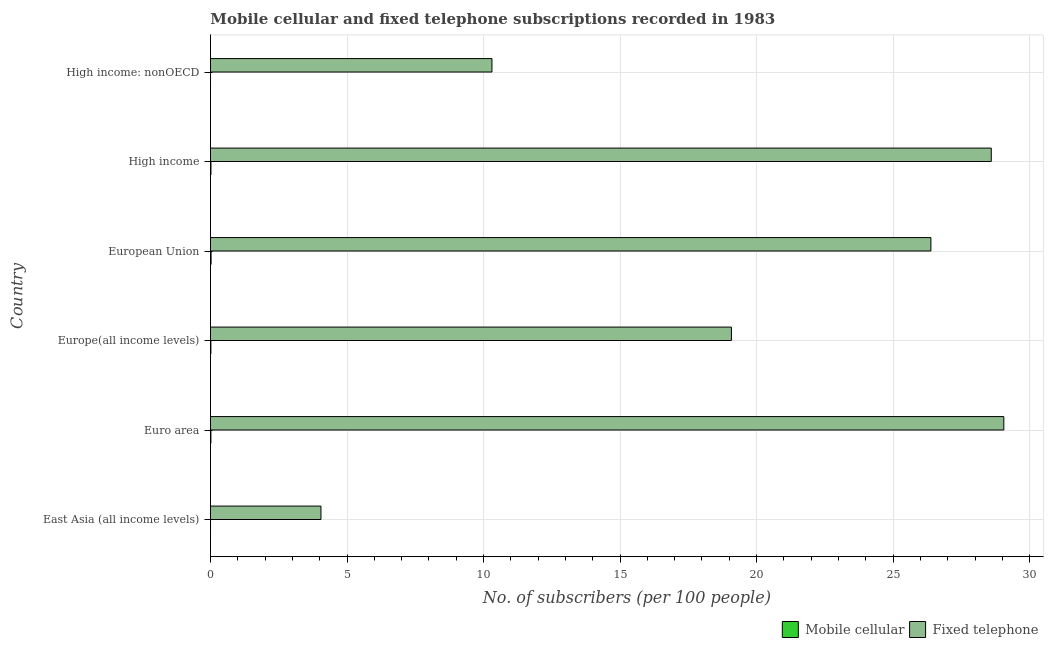How many groups of bars are there?
Your answer should be very brief. 6. Are the number of bars on each tick of the Y-axis equal?
Make the answer very short. Yes. What is the label of the 4th group of bars from the top?
Make the answer very short. Europe(all income levels). What is the number of fixed telephone subscribers in High income?
Keep it short and to the point. 28.59. Across all countries, what is the maximum number of fixed telephone subscribers?
Offer a terse response. 29.05. Across all countries, what is the minimum number of fixed telephone subscribers?
Ensure brevity in your answer.  4.05. In which country was the number of fixed telephone subscribers minimum?
Provide a succinct answer. East Asia (all income levels). What is the total number of mobile cellular subscribers in the graph?
Make the answer very short. 0.07. What is the difference between the number of fixed telephone subscribers in East Asia (all income levels) and that in Europe(all income levels)?
Provide a succinct answer. -15.03. What is the difference between the number of fixed telephone subscribers in High income and the number of mobile cellular subscribers in Euro area?
Keep it short and to the point. 28.58. What is the average number of fixed telephone subscribers per country?
Your answer should be very brief. 19.58. What is the difference between the number of mobile cellular subscribers and number of fixed telephone subscribers in High income?
Your answer should be very brief. -28.58. In how many countries, is the number of mobile cellular subscribers greater than 12 ?
Offer a terse response. 0. What is the ratio of the number of mobile cellular subscribers in Europe(all income levels) to that in European Union?
Offer a terse response. 0.7. What is the difference between the highest and the second highest number of mobile cellular subscribers?
Give a very brief answer. 0.01. Is the sum of the number of fixed telephone subscribers in East Asia (all income levels) and Europe(all income levels) greater than the maximum number of mobile cellular subscribers across all countries?
Provide a short and direct response. Yes. What does the 1st bar from the top in European Union represents?
Your answer should be compact. Fixed telephone. What does the 2nd bar from the bottom in Euro area represents?
Offer a terse response. Fixed telephone. What is the difference between two consecutive major ticks on the X-axis?
Your answer should be compact. 5. Does the graph contain any zero values?
Give a very brief answer. No. What is the title of the graph?
Keep it short and to the point. Mobile cellular and fixed telephone subscriptions recorded in 1983. Does "Revenue" appear as one of the legend labels in the graph?
Your answer should be compact. No. What is the label or title of the X-axis?
Your response must be concise. No. of subscribers (per 100 people). What is the No. of subscribers (per 100 people) in Mobile cellular in East Asia (all income levels)?
Offer a very short reply. 0. What is the No. of subscribers (per 100 people) of Fixed telephone in East Asia (all income levels)?
Ensure brevity in your answer.  4.05. What is the No. of subscribers (per 100 people) of Mobile cellular in Euro area?
Offer a terse response. 0.02. What is the No. of subscribers (per 100 people) in Fixed telephone in Euro area?
Provide a short and direct response. 29.05. What is the No. of subscribers (per 100 people) of Mobile cellular in Europe(all income levels)?
Provide a succinct answer. 0.02. What is the No. of subscribers (per 100 people) in Fixed telephone in Europe(all income levels)?
Provide a short and direct response. 19.08. What is the No. of subscribers (per 100 people) in Mobile cellular in European Union?
Offer a very short reply. 0.02. What is the No. of subscribers (per 100 people) of Fixed telephone in European Union?
Provide a succinct answer. 26.38. What is the No. of subscribers (per 100 people) in Mobile cellular in High income?
Make the answer very short. 0.02. What is the No. of subscribers (per 100 people) in Fixed telephone in High income?
Provide a short and direct response. 28.59. What is the No. of subscribers (per 100 people) in Mobile cellular in High income: nonOECD?
Keep it short and to the point. 0. What is the No. of subscribers (per 100 people) in Fixed telephone in High income: nonOECD?
Offer a very short reply. 10.31. Across all countries, what is the maximum No. of subscribers (per 100 people) of Mobile cellular?
Offer a terse response. 0.02. Across all countries, what is the maximum No. of subscribers (per 100 people) of Fixed telephone?
Give a very brief answer. 29.05. Across all countries, what is the minimum No. of subscribers (per 100 people) in Mobile cellular?
Make the answer very short. 0. Across all countries, what is the minimum No. of subscribers (per 100 people) in Fixed telephone?
Your answer should be compact. 4.05. What is the total No. of subscribers (per 100 people) of Mobile cellular in the graph?
Provide a short and direct response. 0.07. What is the total No. of subscribers (per 100 people) of Fixed telephone in the graph?
Your answer should be very brief. 117.46. What is the difference between the No. of subscribers (per 100 people) of Mobile cellular in East Asia (all income levels) and that in Euro area?
Give a very brief answer. -0.01. What is the difference between the No. of subscribers (per 100 people) of Fixed telephone in East Asia (all income levels) and that in Euro area?
Make the answer very short. -25.01. What is the difference between the No. of subscribers (per 100 people) of Mobile cellular in East Asia (all income levels) and that in Europe(all income levels)?
Ensure brevity in your answer.  -0.01. What is the difference between the No. of subscribers (per 100 people) in Fixed telephone in East Asia (all income levels) and that in Europe(all income levels)?
Your response must be concise. -15.03. What is the difference between the No. of subscribers (per 100 people) of Mobile cellular in East Asia (all income levels) and that in European Union?
Make the answer very short. -0.02. What is the difference between the No. of subscribers (per 100 people) of Fixed telephone in East Asia (all income levels) and that in European Union?
Offer a very short reply. -22.34. What is the difference between the No. of subscribers (per 100 people) in Mobile cellular in East Asia (all income levels) and that in High income?
Your answer should be very brief. -0.02. What is the difference between the No. of subscribers (per 100 people) in Fixed telephone in East Asia (all income levels) and that in High income?
Offer a very short reply. -24.55. What is the difference between the No. of subscribers (per 100 people) in Mobile cellular in East Asia (all income levels) and that in High income: nonOECD?
Offer a terse response. 0. What is the difference between the No. of subscribers (per 100 people) in Fixed telephone in East Asia (all income levels) and that in High income: nonOECD?
Provide a succinct answer. -6.26. What is the difference between the No. of subscribers (per 100 people) of Mobile cellular in Euro area and that in Europe(all income levels)?
Provide a short and direct response. 0. What is the difference between the No. of subscribers (per 100 people) in Fixed telephone in Euro area and that in Europe(all income levels)?
Provide a succinct answer. 9.98. What is the difference between the No. of subscribers (per 100 people) of Mobile cellular in Euro area and that in European Union?
Make the answer very short. -0.01. What is the difference between the No. of subscribers (per 100 people) in Fixed telephone in Euro area and that in European Union?
Offer a terse response. 2.67. What is the difference between the No. of subscribers (per 100 people) of Mobile cellular in Euro area and that in High income?
Keep it short and to the point. -0. What is the difference between the No. of subscribers (per 100 people) of Fixed telephone in Euro area and that in High income?
Ensure brevity in your answer.  0.46. What is the difference between the No. of subscribers (per 100 people) of Mobile cellular in Euro area and that in High income: nonOECD?
Ensure brevity in your answer.  0.01. What is the difference between the No. of subscribers (per 100 people) in Fixed telephone in Euro area and that in High income: nonOECD?
Offer a very short reply. 18.75. What is the difference between the No. of subscribers (per 100 people) of Mobile cellular in Europe(all income levels) and that in European Union?
Provide a succinct answer. -0.01. What is the difference between the No. of subscribers (per 100 people) in Fixed telephone in Europe(all income levels) and that in European Union?
Offer a terse response. -7.31. What is the difference between the No. of subscribers (per 100 people) in Mobile cellular in Europe(all income levels) and that in High income?
Offer a very short reply. -0. What is the difference between the No. of subscribers (per 100 people) of Fixed telephone in Europe(all income levels) and that in High income?
Your response must be concise. -9.52. What is the difference between the No. of subscribers (per 100 people) in Mobile cellular in Europe(all income levels) and that in High income: nonOECD?
Your answer should be compact. 0.01. What is the difference between the No. of subscribers (per 100 people) in Fixed telephone in Europe(all income levels) and that in High income: nonOECD?
Provide a succinct answer. 8.77. What is the difference between the No. of subscribers (per 100 people) of Mobile cellular in European Union and that in High income?
Offer a terse response. 0. What is the difference between the No. of subscribers (per 100 people) of Fixed telephone in European Union and that in High income?
Your response must be concise. -2.21. What is the difference between the No. of subscribers (per 100 people) of Mobile cellular in European Union and that in High income: nonOECD?
Give a very brief answer. 0.02. What is the difference between the No. of subscribers (per 100 people) of Fixed telephone in European Union and that in High income: nonOECD?
Offer a terse response. 16.08. What is the difference between the No. of subscribers (per 100 people) in Mobile cellular in High income and that in High income: nonOECD?
Your answer should be very brief. 0.02. What is the difference between the No. of subscribers (per 100 people) of Fixed telephone in High income and that in High income: nonOECD?
Give a very brief answer. 18.29. What is the difference between the No. of subscribers (per 100 people) in Mobile cellular in East Asia (all income levels) and the No. of subscribers (per 100 people) in Fixed telephone in Euro area?
Make the answer very short. -29.05. What is the difference between the No. of subscribers (per 100 people) in Mobile cellular in East Asia (all income levels) and the No. of subscribers (per 100 people) in Fixed telephone in Europe(all income levels)?
Your answer should be compact. -19.08. What is the difference between the No. of subscribers (per 100 people) of Mobile cellular in East Asia (all income levels) and the No. of subscribers (per 100 people) of Fixed telephone in European Union?
Ensure brevity in your answer.  -26.38. What is the difference between the No. of subscribers (per 100 people) in Mobile cellular in East Asia (all income levels) and the No. of subscribers (per 100 people) in Fixed telephone in High income?
Provide a short and direct response. -28.59. What is the difference between the No. of subscribers (per 100 people) in Mobile cellular in East Asia (all income levels) and the No. of subscribers (per 100 people) in Fixed telephone in High income: nonOECD?
Your answer should be compact. -10.31. What is the difference between the No. of subscribers (per 100 people) in Mobile cellular in Euro area and the No. of subscribers (per 100 people) in Fixed telephone in Europe(all income levels)?
Ensure brevity in your answer.  -19.06. What is the difference between the No. of subscribers (per 100 people) in Mobile cellular in Euro area and the No. of subscribers (per 100 people) in Fixed telephone in European Union?
Your response must be concise. -26.37. What is the difference between the No. of subscribers (per 100 people) in Mobile cellular in Euro area and the No. of subscribers (per 100 people) in Fixed telephone in High income?
Provide a succinct answer. -28.58. What is the difference between the No. of subscribers (per 100 people) of Mobile cellular in Euro area and the No. of subscribers (per 100 people) of Fixed telephone in High income: nonOECD?
Your answer should be compact. -10.29. What is the difference between the No. of subscribers (per 100 people) in Mobile cellular in Europe(all income levels) and the No. of subscribers (per 100 people) in Fixed telephone in European Union?
Keep it short and to the point. -26.37. What is the difference between the No. of subscribers (per 100 people) in Mobile cellular in Europe(all income levels) and the No. of subscribers (per 100 people) in Fixed telephone in High income?
Your answer should be very brief. -28.58. What is the difference between the No. of subscribers (per 100 people) in Mobile cellular in Europe(all income levels) and the No. of subscribers (per 100 people) in Fixed telephone in High income: nonOECD?
Provide a succinct answer. -10.29. What is the difference between the No. of subscribers (per 100 people) of Mobile cellular in European Union and the No. of subscribers (per 100 people) of Fixed telephone in High income?
Your response must be concise. -28.57. What is the difference between the No. of subscribers (per 100 people) of Mobile cellular in European Union and the No. of subscribers (per 100 people) of Fixed telephone in High income: nonOECD?
Ensure brevity in your answer.  -10.29. What is the difference between the No. of subscribers (per 100 people) in Mobile cellular in High income and the No. of subscribers (per 100 people) in Fixed telephone in High income: nonOECD?
Your response must be concise. -10.29. What is the average No. of subscribers (per 100 people) in Mobile cellular per country?
Ensure brevity in your answer.  0.01. What is the average No. of subscribers (per 100 people) in Fixed telephone per country?
Your answer should be very brief. 19.58. What is the difference between the No. of subscribers (per 100 people) in Mobile cellular and No. of subscribers (per 100 people) in Fixed telephone in East Asia (all income levels)?
Make the answer very short. -4.04. What is the difference between the No. of subscribers (per 100 people) in Mobile cellular and No. of subscribers (per 100 people) in Fixed telephone in Euro area?
Offer a very short reply. -29.04. What is the difference between the No. of subscribers (per 100 people) of Mobile cellular and No. of subscribers (per 100 people) of Fixed telephone in Europe(all income levels)?
Offer a terse response. -19.06. What is the difference between the No. of subscribers (per 100 people) in Mobile cellular and No. of subscribers (per 100 people) in Fixed telephone in European Union?
Provide a succinct answer. -26.36. What is the difference between the No. of subscribers (per 100 people) of Mobile cellular and No. of subscribers (per 100 people) of Fixed telephone in High income?
Your answer should be compact. -28.58. What is the difference between the No. of subscribers (per 100 people) in Mobile cellular and No. of subscribers (per 100 people) in Fixed telephone in High income: nonOECD?
Make the answer very short. -10.31. What is the ratio of the No. of subscribers (per 100 people) in Mobile cellular in East Asia (all income levels) to that in Euro area?
Provide a succinct answer. 0.1. What is the ratio of the No. of subscribers (per 100 people) of Fixed telephone in East Asia (all income levels) to that in Euro area?
Make the answer very short. 0.14. What is the ratio of the No. of subscribers (per 100 people) of Mobile cellular in East Asia (all income levels) to that in Europe(all income levels)?
Keep it short and to the point. 0.11. What is the ratio of the No. of subscribers (per 100 people) in Fixed telephone in East Asia (all income levels) to that in Europe(all income levels)?
Your answer should be compact. 0.21. What is the ratio of the No. of subscribers (per 100 people) in Mobile cellular in East Asia (all income levels) to that in European Union?
Your response must be concise. 0.08. What is the ratio of the No. of subscribers (per 100 people) of Fixed telephone in East Asia (all income levels) to that in European Union?
Provide a short and direct response. 0.15. What is the ratio of the No. of subscribers (per 100 people) of Mobile cellular in East Asia (all income levels) to that in High income?
Your response must be concise. 0.1. What is the ratio of the No. of subscribers (per 100 people) in Fixed telephone in East Asia (all income levels) to that in High income?
Your response must be concise. 0.14. What is the ratio of the No. of subscribers (per 100 people) in Mobile cellular in East Asia (all income levels) to that in High income: nonOECD?
Provide a succinct answer. 1.12. What is the ratio of the No. of subscribers (per 100 people) in Fixed telephone in East Asia (all income levels) to that in High income: nonOECD?
Offer a terse response. 0.39. What is the ratio of the No. of subscribers (per 100 people) in Mobile cellular in Euro area to that in Europe(all income levels)?
Your answer should be very brief. 1.02. What is the ratio of the No. of subscribers (per 100 people) of Fixed telephone in Euro area to that in Europe(all income levels)?
Your answer should be very brief. 1.52. What is the ratio of the No. of subscribers (per 100 people) of Mobile cellular in Euro area to that in European Union?
Offer a terse response. 0.72. What is the ratio of the No. of subscribers (per 100 people) in Fixed telephone in Euro area to that in European Union?
Offer a terse response. 1.1. What is the ratio of the No. of subscribers (per 100 people) of Mobile cellular in Euro area to that in High income?
Give a very brief answer. 0.91. What is the ratio of the No. of subscribers (per 100 people) in Fixed telephone in Euro area to that in High income?
Your response must be concise. 1.02. What is the ratio of the No. of subscribers (per 100 people) of Mobile cellular in Euro area to that in High income: nonOECD?
Your answer should be compact. 10.67. What is the ratio of the No. of subscribers (per 100 people) in Fixed telephone in Euro area to that in High income: nonOECD?
Offer a terse response. 2.82. What is the ratio of the No. of subscribers (per 100 people) in Mobile cellular in Europe(all income levels) to that in European Union?
Your answer should be compact. 0.7. What is the ratio of the No. of subscribers (per 100 people) of Fixed telephone in Europe(all income levels) to that in European Union?
Make the answer very short. 0.72. What is the ratio of the No. of subscribers (per 100 people) of Mobile cellular in Europe(all income levels) to that in High income?
Provide a short and direct response. 0.89. What is the ratio of the No. of subscribers (per 100 people) in Fixed telephone in Europe(all income levels) to that in High income?
Offer a terse response. 0.67. What is the ratio of the No. of subscribers (per 100 people) in Mobile cellular in Europe(all income levels) to that in High income: nonOECD?
Keep it short and to the point. 10.44. What is the ratio of the No. of subscribers (per 100 people) of Fixed telephone in Europe(all income levels) to that in High income: nonOECD?
Make the answer very short. 1.85. What is the ratio of the No. of subscribers (per 100 people) in Mobile cellular in European Union to that in High income?
Make the answer very short. 1.26. What is the ratio of the No. of subscribers (per 100 people) in Fixed telephone in European Union to that in High income?
Your answer should be very brief. 0.92. What is the ratio of the No. of subscribers (per 100 people) of Mobile cellular in European Union to that in High income: nonOECD?
Keep it short and to the point. 14.81. What is the ratio of the No. of subscribers (per 100 people) in Fixed telephone in European Union to that in High income: nonOECD?
Your answer should be compact. 2.56. What is the ratio of the No. of subscribers (per 100 people) of Mobile cellular in High income to that in High income: nonOECD?
Your response must be concise. 11.77. What is the ratio of the No. of subscribers (per 100 people) in Fixed telephone in High income to that in High income: nonOECD?
Keep it short and to the point. 2.77. What is the difference between the highest and the second highest No. of subscribers (per 100 people) of Mobile cellular?
Your answer should be compact. 0. What is the difference between the highest and the second highest No. of subscribers (per 100 people) in Fixed telephone?
Make the answer very short. 0.46. What is the difference between the highest and the lowest No. of subscribers (per 100 people) in Mobile cellular?
Your answer should be compact. 0.02. What is the difference between the highest and the lowest No. of subscribers (per 100 people) in Fixed telephone?
Offer a terse response. 25.01. 